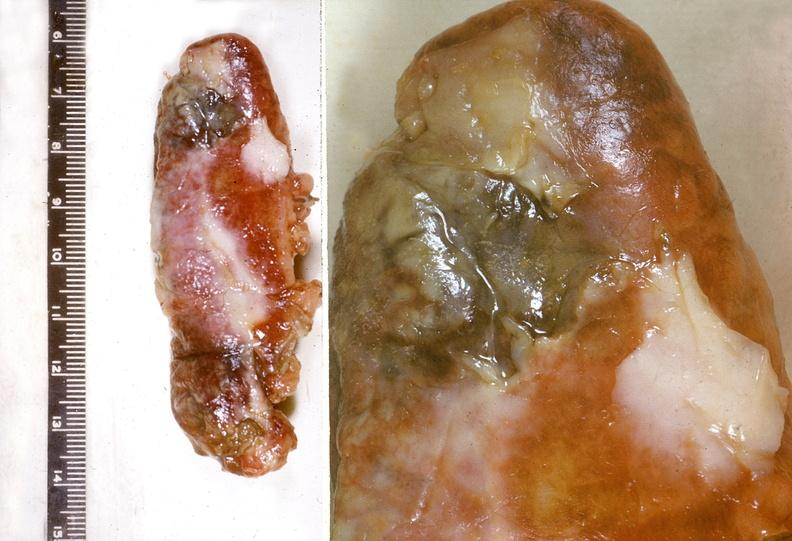where does this belong to?
Answer the question using a single word or phrase. Gastrointestinal system 